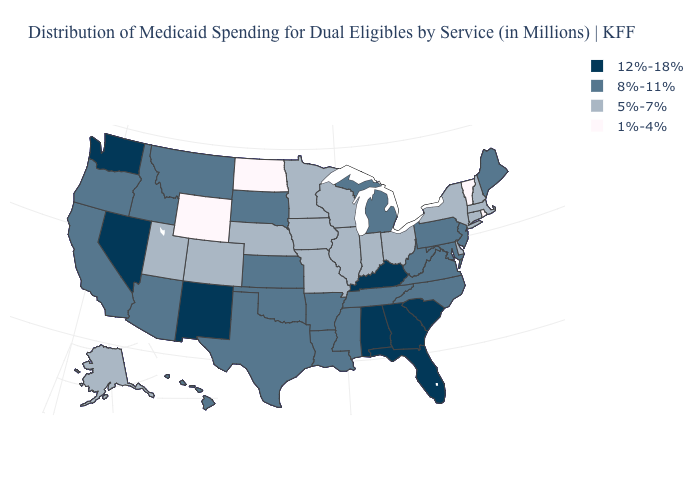Name the states that have a value in the range 1%-4%?
Write a very short answer. North Dakota, Rhode Island, Vermont, Wyoming. Does the first symbol in the legend represent the smallest category?
Quick response, please. No. How many symbols are there in the legend?
Keep it brief. 4. What is the lowest value in the MidWest?
Be succinct. 1%-4%. Does the first symbol in the legend represent the smallest category?
Quick response, please. No. Name the states that have a value in the range 8%-11%?
Concise answer only. Arizona, Arkansas, California, Hawaii, Idaho, Kansas, Louisiana, Maine, Maryland, Michigan, Mississippi, Montana, New Jersey, North Carolina, Oklahoma, Oregon, Pennsylvania, South Dakota, Tennessee, Texas, Virginia, West Virginia. Which states have the lowest value in the MidWest?
Write a very short answer. North Dakota. Does the first symbol in the legend represent the smallest category?
Be succinct. No. Which states hav the highest value in the MidWest?
Concise answer only. Kansas, Michigan, South Dakota. Does the first symbol in the legend represent the smallest category?
Quick response, please. No. Does Pennsylvania have the highest value in the Northeast?
Concise answer only. Yes. Name the states that have a value in the range 8%-11%?
Be succinct. Arizona, Arkansas, California, Hawaii, Idaho, Kansas, Louisiana, Maine, Maryland, Michigan, Mississippi, Montana, New Jersey, North Carolina, Oklahoma, Oregon, Pennsylvania, South Dakota, Tennessee, Texas, Virginia, West Virginia. Among the states that border Missouri , does Kentucky have the highest value?
Concise answer only. Yes. How many symbols are there in the legend?
Concise answer only. 4. Does the map have missing data?
Be succinct. No. 